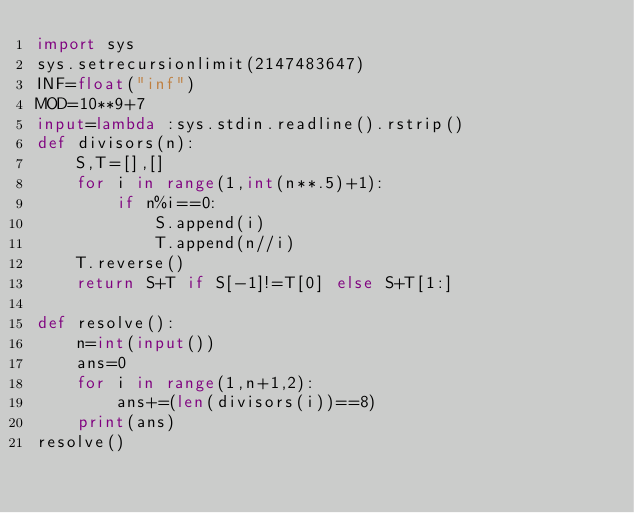Convert code to text. <code><loc_0><loc_0><loc_500><loc_500><_Python_>import sys
sys.setrecursionlimit(2147483647)
INF=float("inf")
MOD=10**9+7
input=lambda :sys.stdin.readline().rstrip()
def divisors(n):
    S,T=[],[]
    for i in range(1,int(n**.5)+1):
        if n%i==0:
            S.append(i)
            T.append(n//i)
    T.reverse()
    return S+T if S[-1]!=T[0] else S+T[1:]

def resolve():
    n=int(input())
    ans=0
    for i in range(1,n+1,2):
        ans+=(len(divisors(i))==8)
    print(ans)
resolve()</code> 